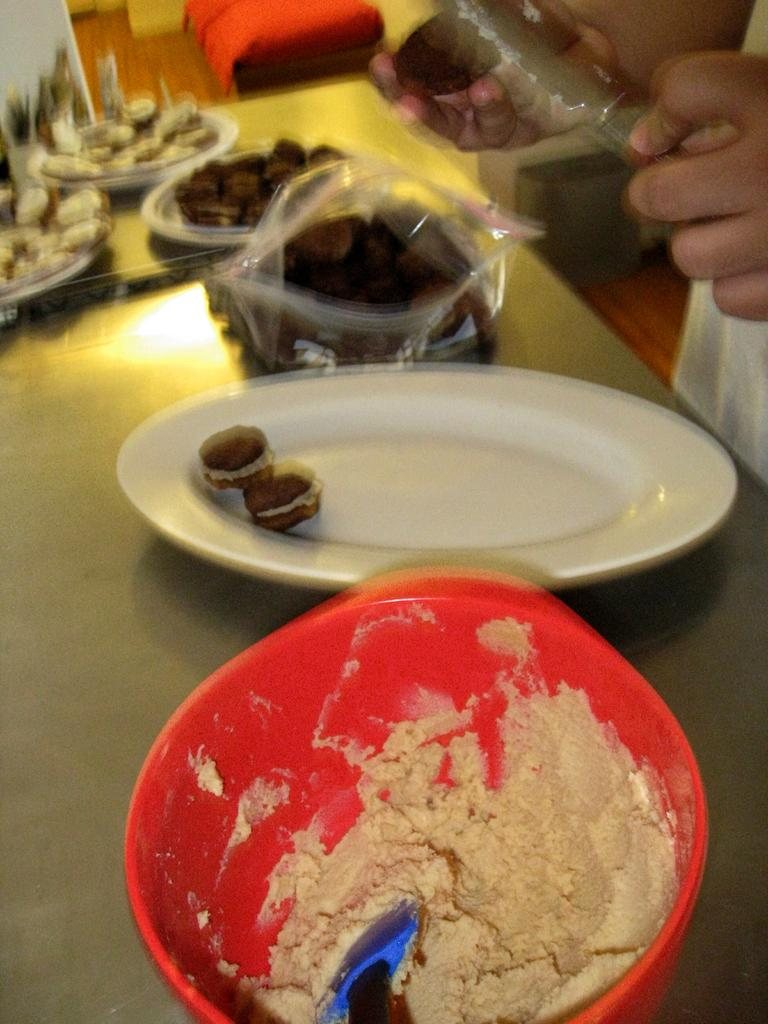What is in the bowl that is visible in the image? There is a bowl with flour in the image. What other objects can be seen on the table in the image? There is a plate on the table in the image. What is the opinion of the gun in the image? There is no gun present in the image, so it is not possible to determine its opinion. 